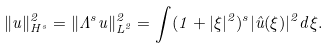Convert formula to latex. <formula><loc_0><loc_0><loc_500><loc_500>\| u \| _ { H ^ { s } } ^ { 2 } = \| \Lambda ^ { s } u \| _ { L ^ { 2 } } ^ { 2 } = \int ( 1 + | \xi | ^ { 2 } ) ^ { s } | \hat { u } ( \xi ) | ^ { 2 } d \xi .</formula> 